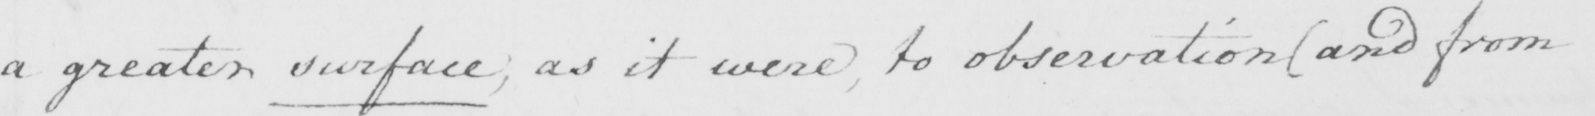Transcribe the text shown in this historical manuscript line. a greater surface; as it were, to observation ( and from 